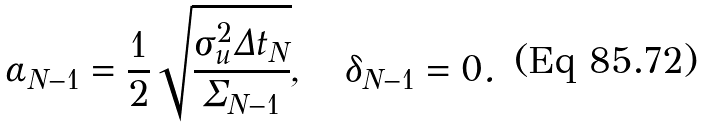<formula> <loc_0><loc_0><loc_500><loc_500>\alpha _ { N - 1 } = \frac { 1 } { 2 } \sqrt { \frac { \sigma ^ { 2 } _ { u } \Delta { t _ { N } } } { \Sigma _ { N - 1 } } } , \quad \delta _ { N - 1 } = 0 .</formula> 